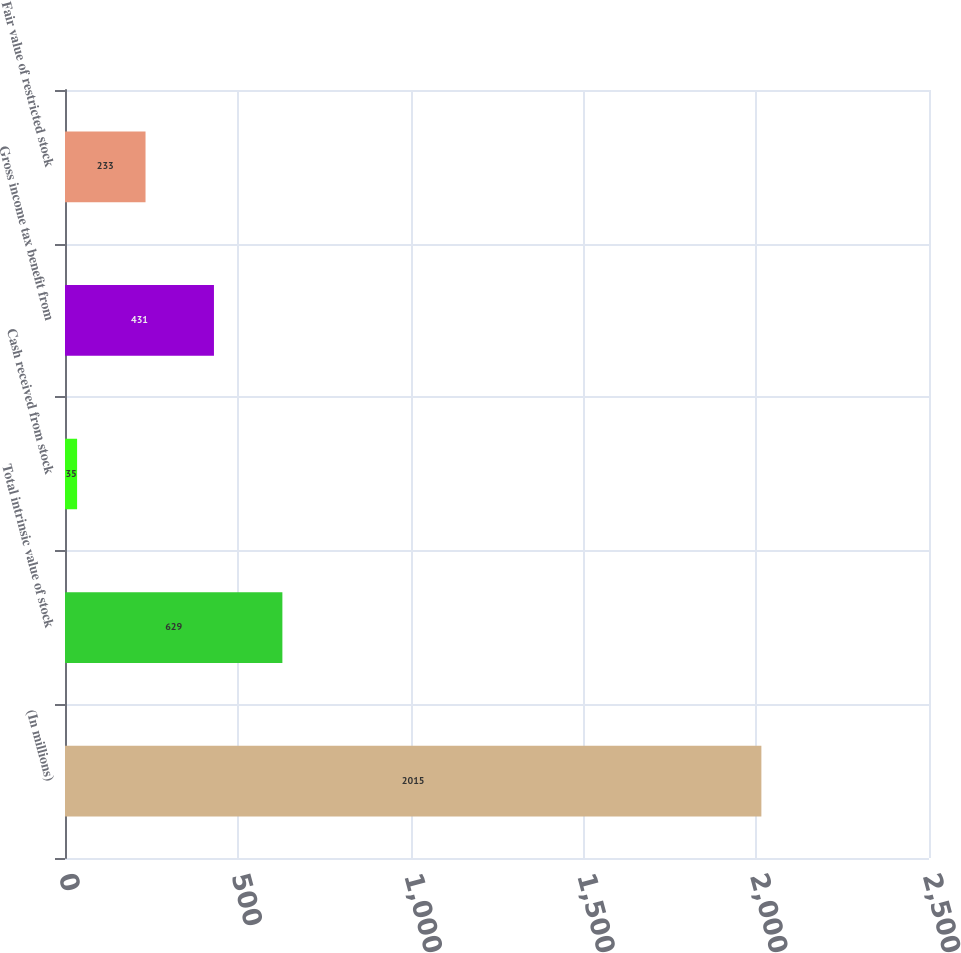<chart> <loc_0><loc_0><loc_500><loc_500><bar_chart><fcel>(In millions)<fcel>Total intrinsic value of stock<fcel>Cash received from stock<fcel>Gross income tax benefit from<fcel>Fair value of restricted stock<nl><fcel>2015<fcel>629<fcel>35<fcel>431<fcel>233<nl></chart> 